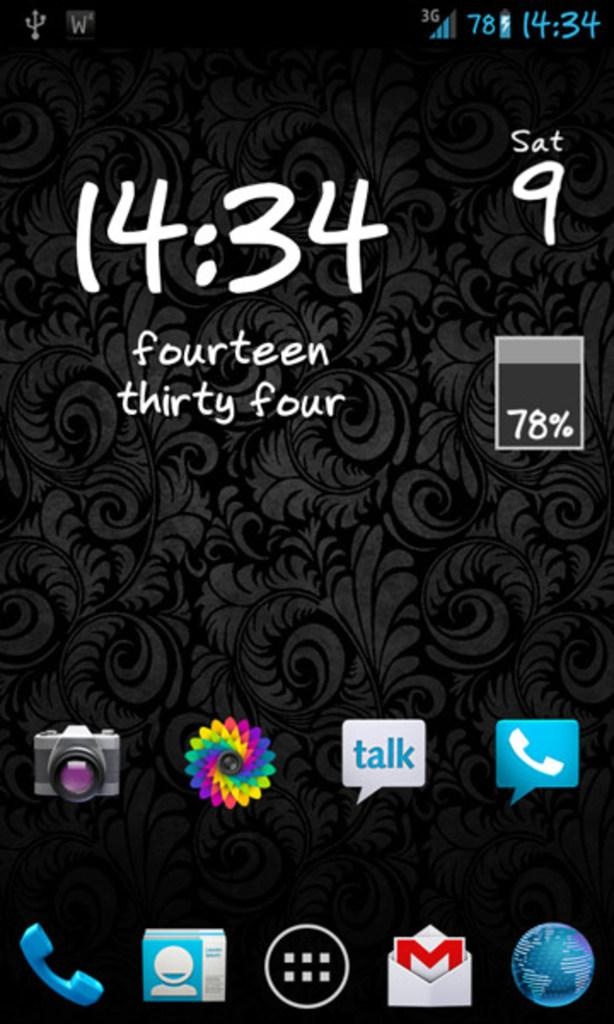<image>
Describe the image concisely. a phone with the time of 14:34 on it 